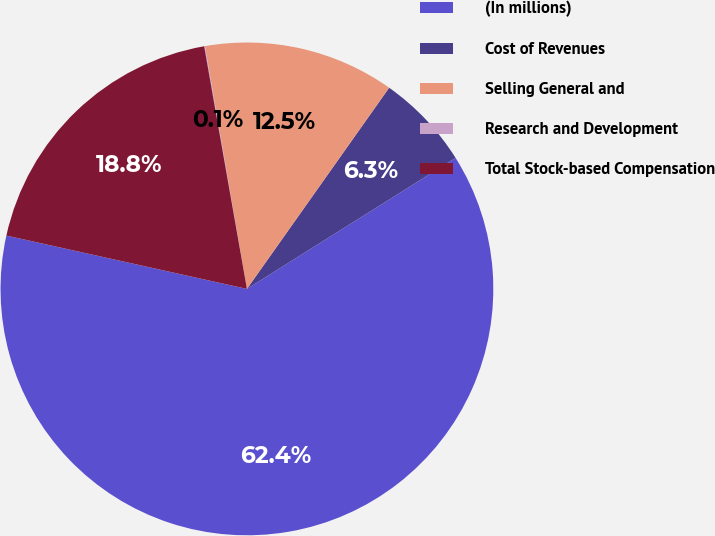Convert chart. <chart><loc_0><loc_0><loc_500><loc_500><pie_chart><fcel>(In millions)<fcel>Cost of Revenues<fcel>Selling General and<fcel>Research and Development<fcel>Total Stock-based Compensation<nl><fcel>62.39%<fcel>6.28%<fcel>12.52%<fcel>0.05%<fcel>18.75%<nl></chart> 